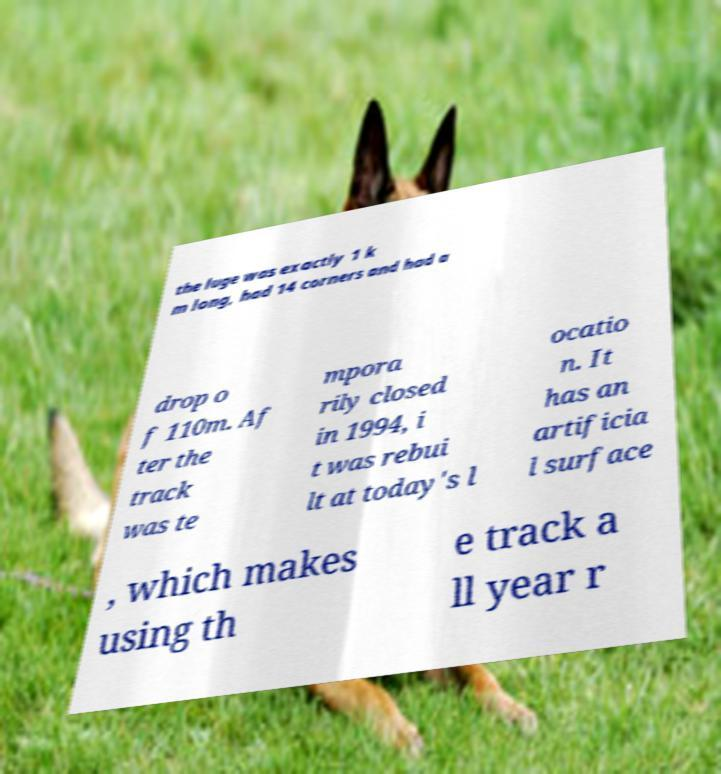What messages or text are displayed in this image? I need them in a readable, typed format. the luge was exactly 1 k m long, had 14 corners and had a drop o f 110m. Af ter the track was te mpora rily closed in 1994, i t was rebui lt at today's l ocatio n. It has an artificia l surface , which makes using th e track a ll year r 